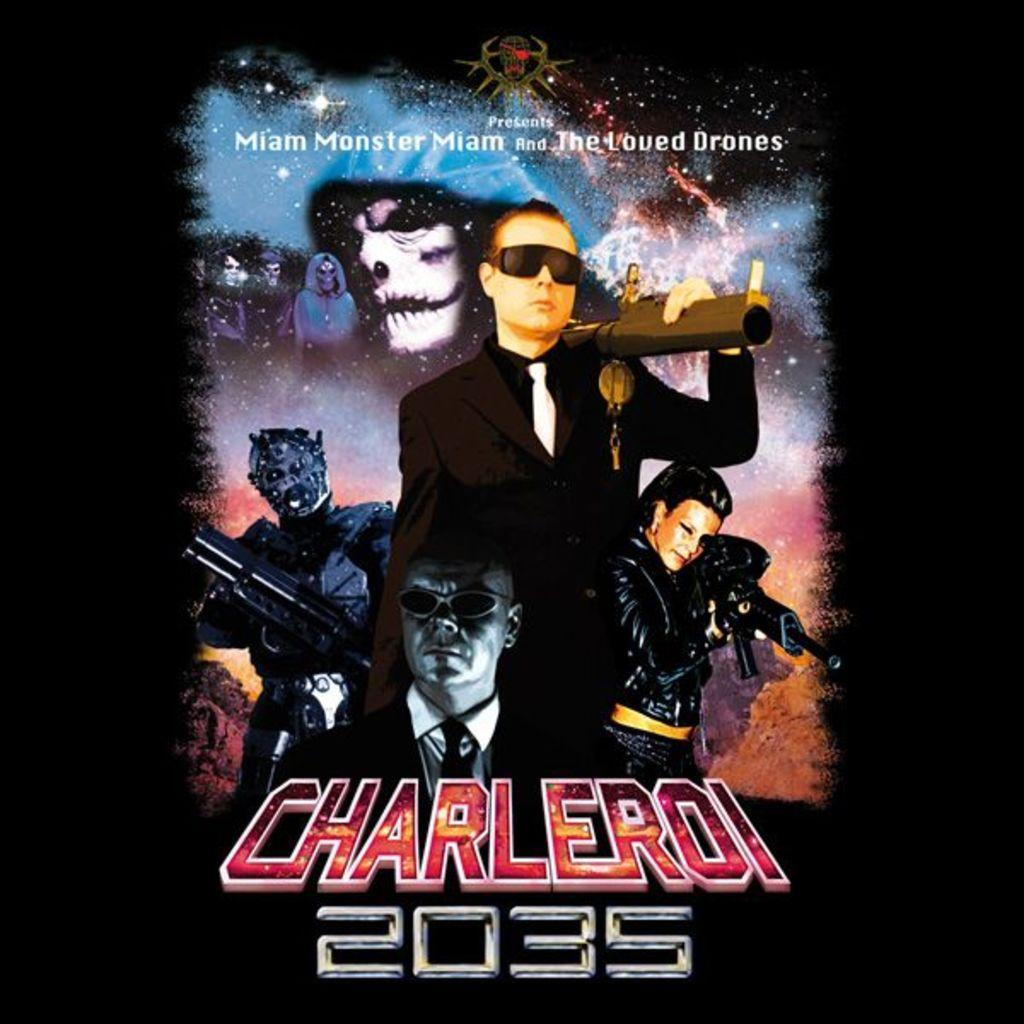<image>
Give a short and clear explanation of the subsequent image. An ad has the title Charleroi 2035 on it below a picture of a man in glasses. 